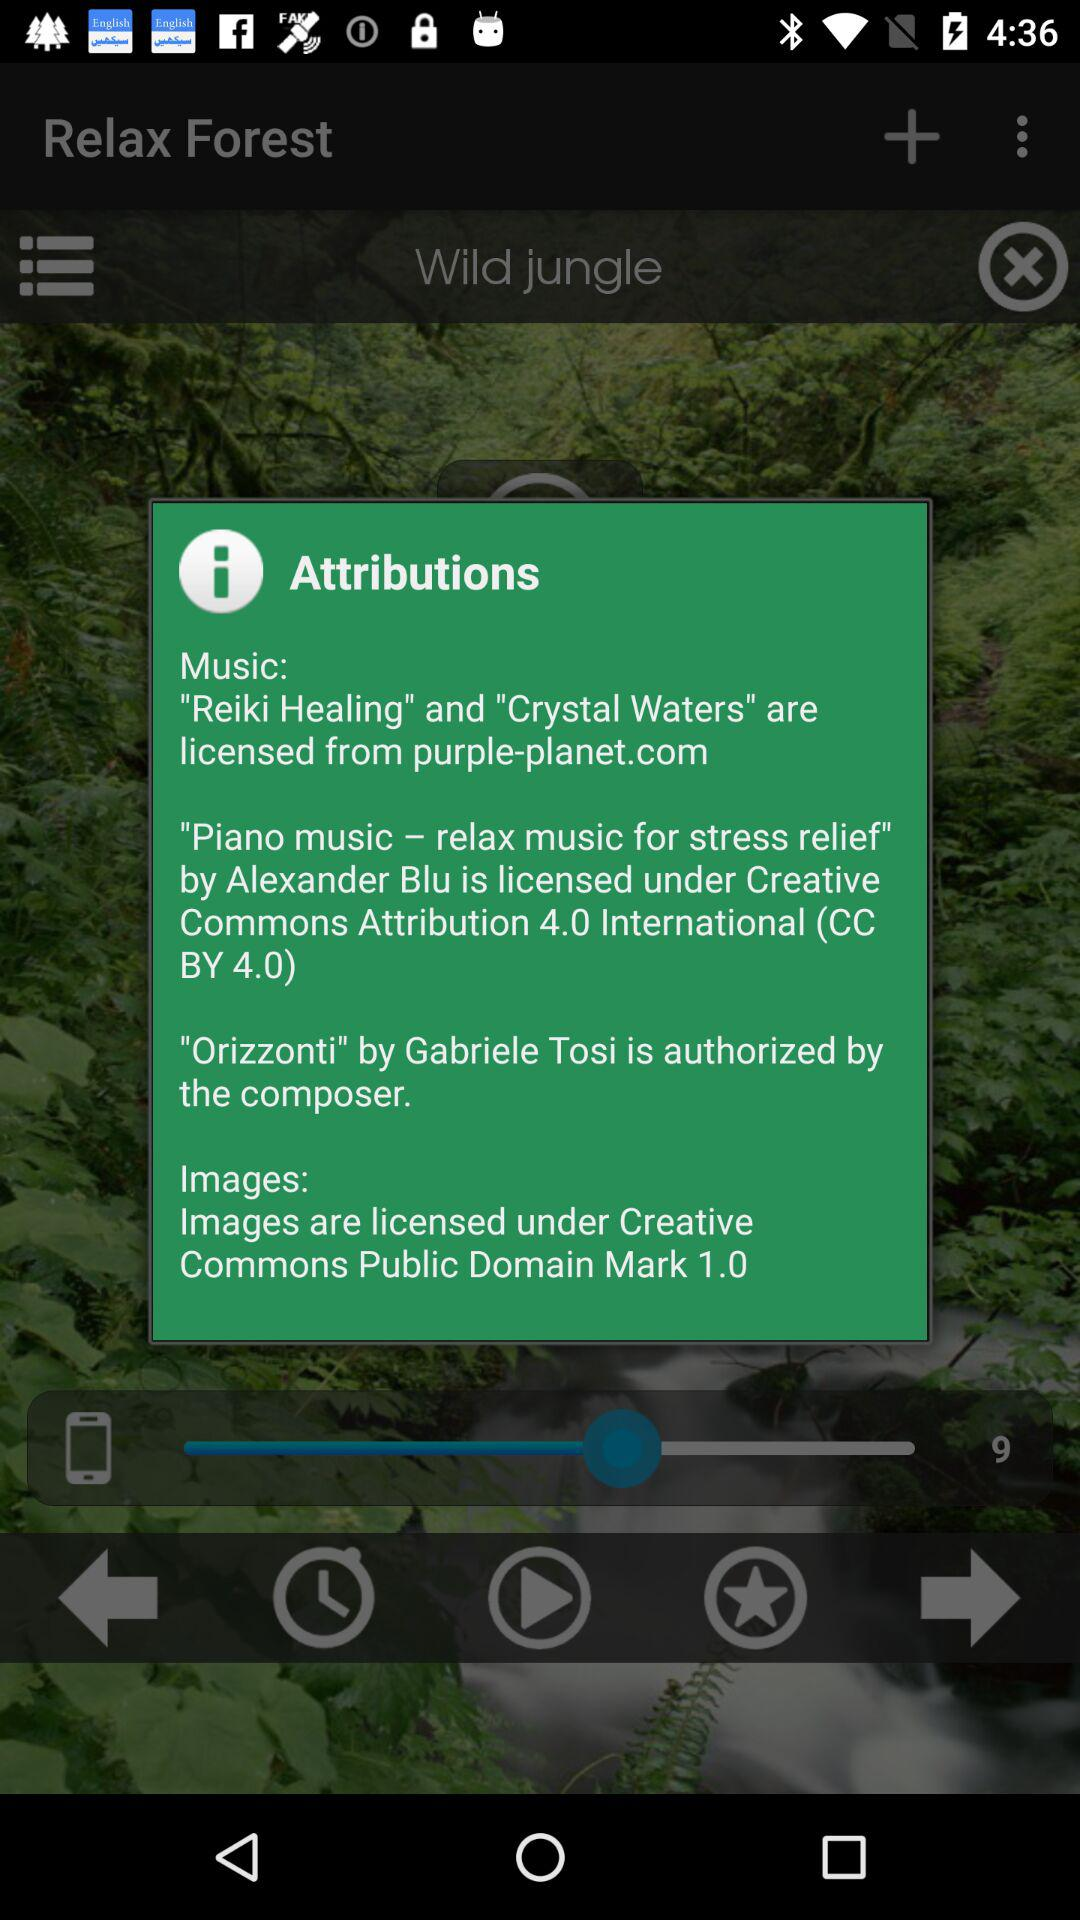Which music is licensed from purple-planet.com? Music licensed from purple-planet.com are "Reiki Healing" and "Crystal Waters". 